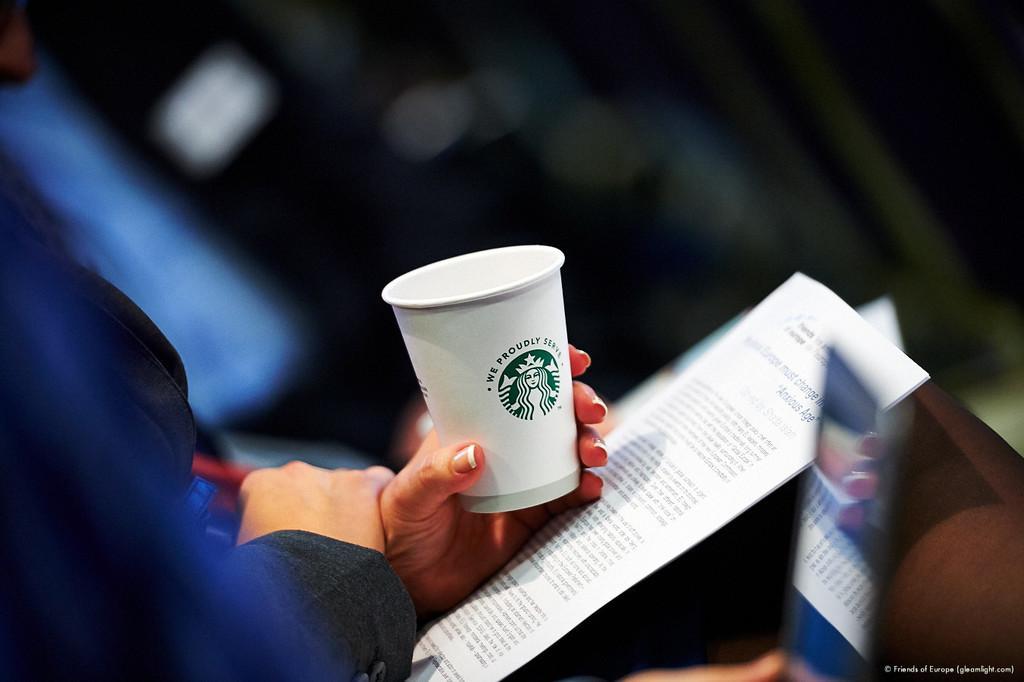Please provide a concise description of this image. In the middle of the image a person is sitting and holding a paper and cup. At the top of the image is blur. 